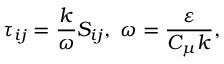<formula> <loc_0><loc_0><loc_500><loc_500>\tau _ { i j } = \frac { k } { \omega } S _ { i j } , \, \omega = \frac { \varepsilon } { C _ { \mu } k } ,</formula> 